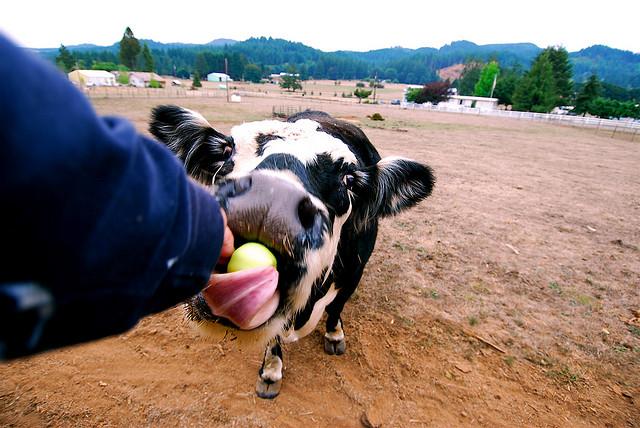Is this a wild pig?
Concise answer only. No. What is the animal eating?
Short answer required. Apple. Is the animal friendly?
Short answer required. Yes. 